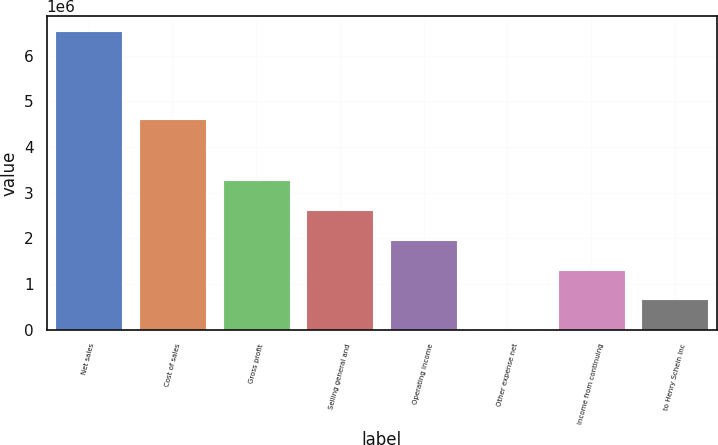Convert chart to OTSL. <chart><loc_0><loc_0><loc_500><loc_500><bar_chart><fcel>Net sales<fcel>Cost of sales<fcel>Gross profit<fcel>Selling general and<fcel>Operating income<fcel>Other expense net<fcel>Income from continuing<fcel>to Henry Schein Inc<nl><fcel>6.53834e+06<fcel>4.62152e+06<fcel>3.27485e+06<fcel>2.62215e+06<fcel>1.96946e+06<fcel>11365<fcel>1.31676e+06<fcel>664062<nl></chart> 